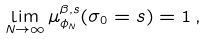<formula> <loc_0><loc_0><loc_500><loc_500>\lim _ { N \to \infty } \mu _ { \phi _ { N } } ^ { \beta , s } ( \sigma _ { 0 } = s ) = 1 \, ,</formula> 